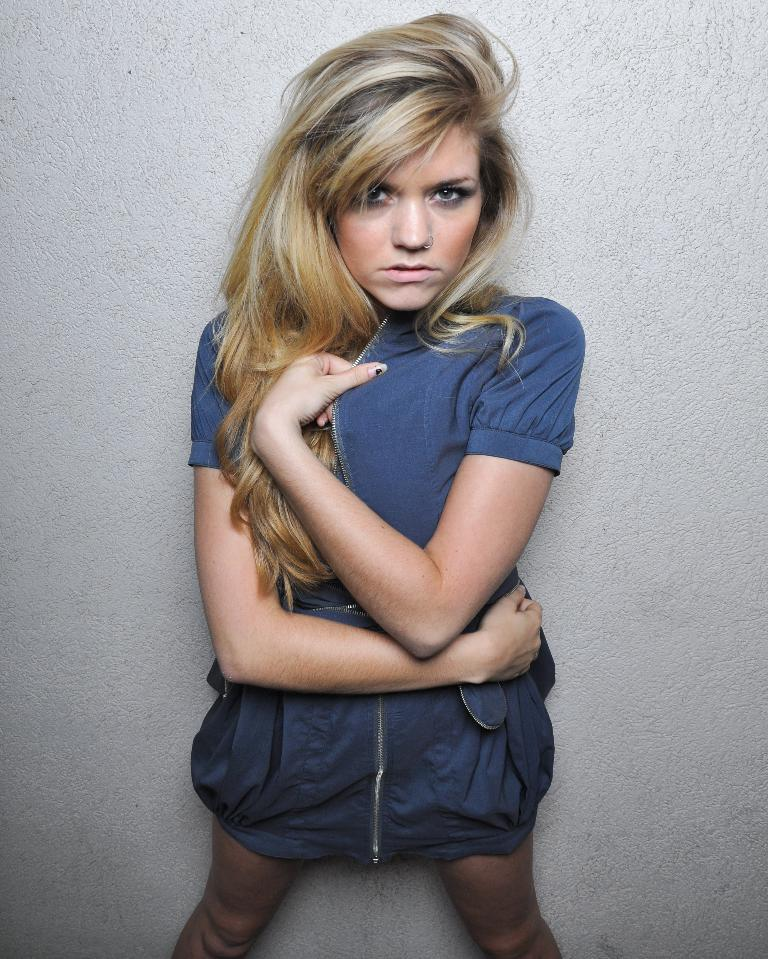Where was the image taken? The image was taken indoors on the floor in the image? What is the background of the image? There is a wall in the background of the image. Can you describe the girl in the image? The girl has long hair and is standing in the middle of the image. Is the girl fighting with someone in the image? No, there is no fight or any indication of conflict in the image. 